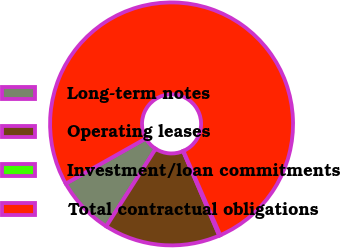<chart> <loc_0><loc_0><loc_500><loc_500><pie_chart><fcel>Long-term notes<fcel>Operating leases<fcel>Investment/loan commitments<fcel>Total contractual obligations<nl><fcel>7.8%<fcel>15.44%<fcel>0.15%<fcel>76.6%<nl></chart> 